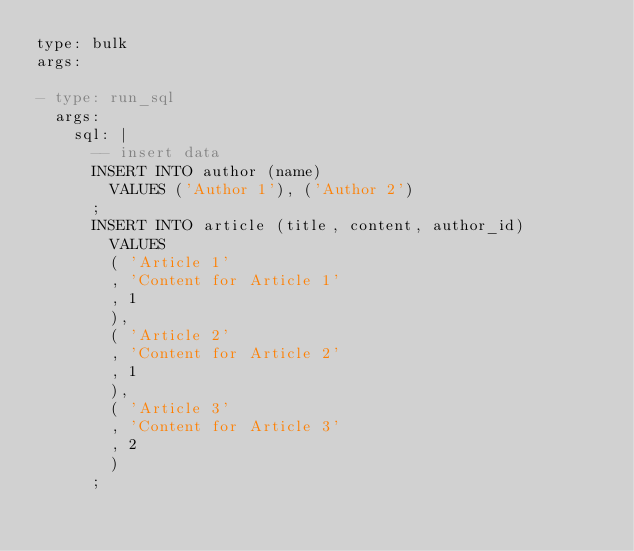<code> <loc_0><loc_0><loc_500><loc_500><_YAML_>type: bulk
args:

- type: run_sql
  args:
    sql: |
      -- insert data
      INSERT INTO author (name)
        VALUES ('Author 1'), ('Author 2')
      ;
      INSERT INTO article (title, content, author_id)
        VALUES
        ( 'Article 1'
        , 'Content for Article 1'
        , 1
        ),
        ( 'Article 2'
        , 'Content for Article 2'
        , 1
        ),
        ( 'Article 3'
        , 'Content for Article 3'
        , 2
        )
      ;

</code> 